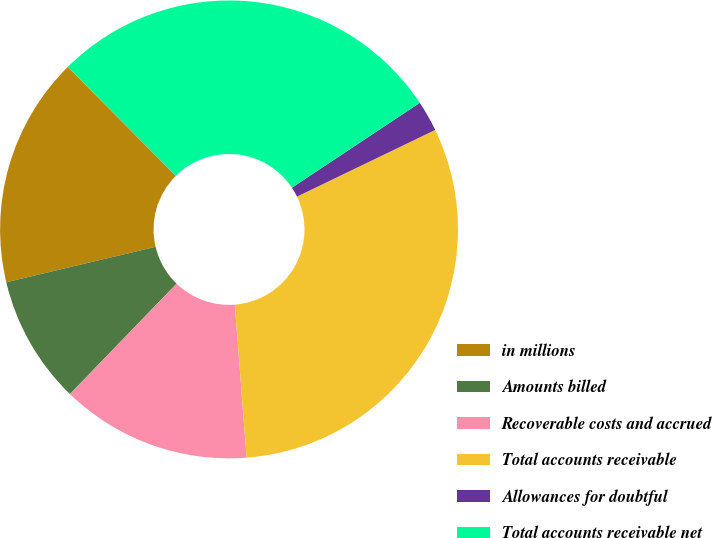<chart> <loc_0><loc_0><loc_500><loc_500><pie_chart><fcel>in millions<fcel>Amounts billed<fcel>Recoverable costs and accrued<fcel>Total accounts receivable<fcel>Allowances for doubtful<fcel>Total accounts receivable net<nl><fcel>16.26%<fcel>9.07%<fcel>13.45%<fcel>30.93%<fcel>2.17%<fcel>28.12%<nl></chart> 